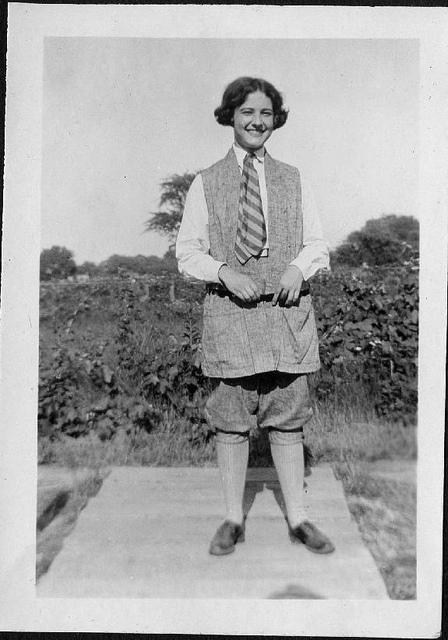How many people are wearing ties?
Give a very brief answer. 1. How many ties can be seen?
Give a very brief answer. 1. 